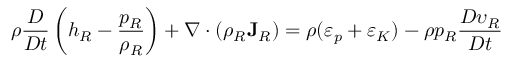<formula> <loc_0><loc_0><loc_500><loc_500>\rho \frac { D } { D t } \left ( h _ { R } - \frac { p _ { R } } { \rho _ { R } } \right ) + \nabla \cdot ( \rho _ { R } { J } _ { R } ) = \rho ( \varepsilon _ { p } + \varepsilon _ { K } ) - \rho p _ { R } \frac { D \upsilon _ { R } } { D t }</formula> 